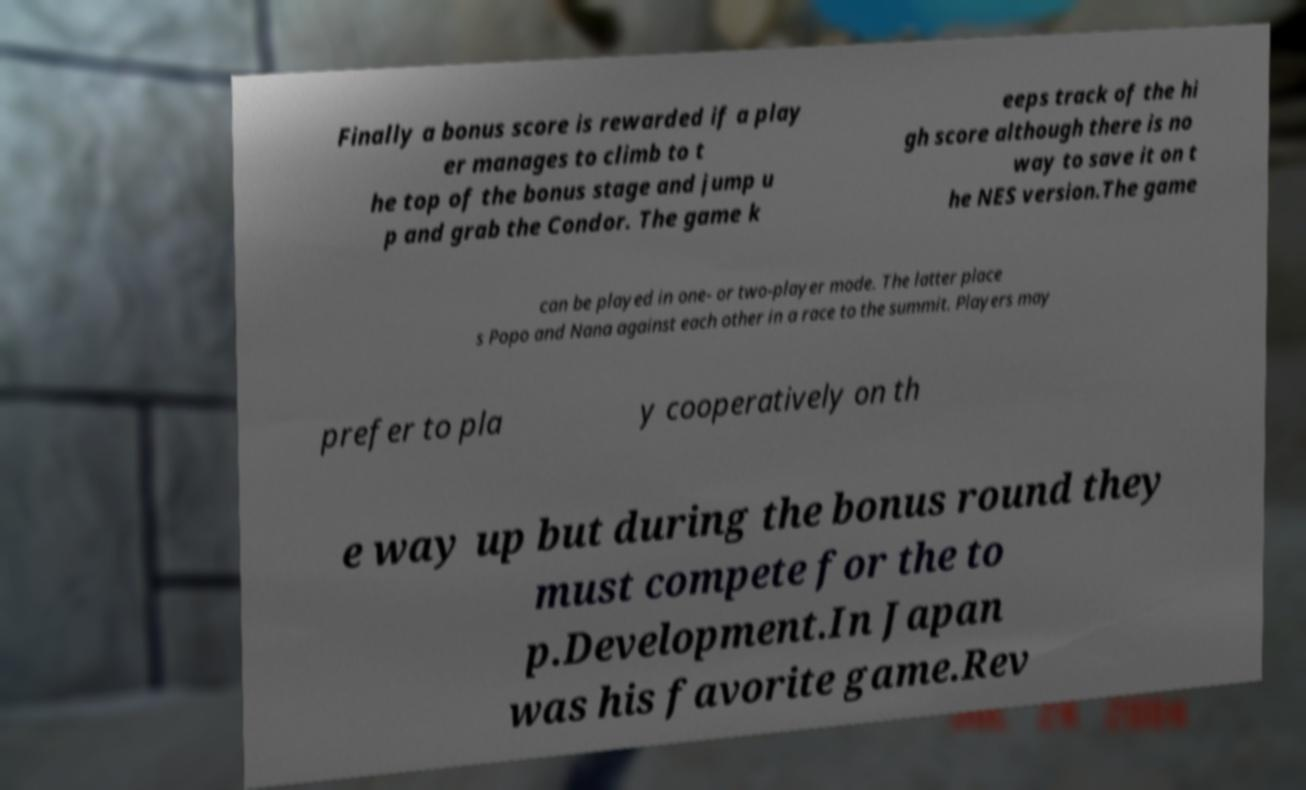Can you accurately transcribe the text from the provided image for me? Finally a bonus score is rewarded if a play er manages to climb to t he top of the bonus stage and jump u p and grab the Condor. The game k eeps track of the hi gh score although there is no way to save it on t he NES version.The game can be played in one- or two-player mode. The latter place s Popo and Nana against each other in a race to the summit. Players may prefer to pla y cooperatively on th e way up but during the bonus round they must compete for the to p.Development.In Japan was his favorite game.Rev 